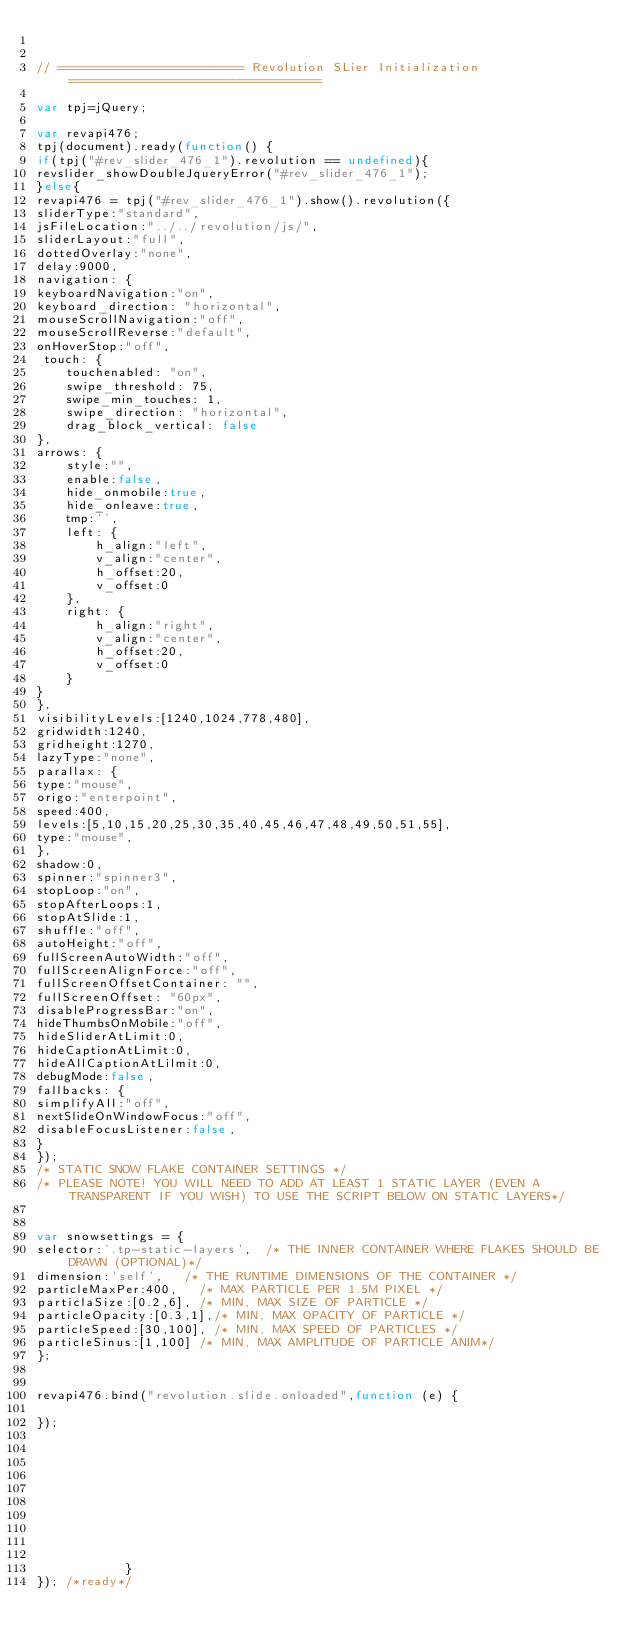<code> <loc_0><loc_0><loc_500><loc_500><_JavaScript_>

// ========================= Revolution SLier Initialization ==================================

var tpj=jQuery;

var revapi476;
tpj(document).ready(function() {
if(tpj("#rev_slider_476_1").revolution == undefined){
revslider_showDoubleJqueryError("#rev_slider_476_1");
}else{
revapi476 = tpj("#rev_slider_476_1").show().revolution({
sliderType:"standard",
jsFileLocation:"../../revolution/js/",
sliderLayout:"full",
dottedOverlay:"none",
delay:9000,
navigation: {
keyboardNavigation:"on",
keyboard_direction: "horizontal",
mouseScrollNavigation:"off",
mouseScrollReverse:"default",
onHoverStop:"off",
 touch: {
    touchenabled: "on",
    swipe_threshold: 75,
    swipe_min_touches: 1,
    swipe_direction: "horizontal",
    drag_block_vertical: false
},
arrows: {
    style:"",
    enable:false,
    hide_onmobile:true,
    hide_onleave:true,
    tmp:'',
    left: {
        h_align:"left",
        v_align:"center",
        h_offset:20,
        v_offset:0
    },
    right: {
        h_align:"right",
        v_align:"center",
        h_offset:20,
        v_offset:0
    }
}
},
visibilityLevels:[1240,1024,778,480],
gridwidth:1240,
gridheight:1270,
lazyType:"none",
parallax: {
type:"mouse",
origo:"enterpoint",
speed:400,
levels:[5,10,15,20,25,30,35,40,45,46,47,48,49,50,51,55],
type:"mouse",
},
shadow:0,
spinner:"spinner3",
stopLoop:"on",
stopAfterLoops:1,
stopAtSlide:1,
shuffle:"off",
autoHeight:"off",
fullScreenAutoWidth:"off",
fullScreenAlignForce:"off",
fullScreenOffsetContainer: "",
fullScreenOffset: "60px",
disableProgressBar:"on",
hideThumbsOnMobile:"off",
hideSliderAtLimit:0,
hideCaptionAtLimit:0,
hideAllCaptionAtLilmit:0,
debugMode:false,
fallbacks: {
simplifyAll:"off",
nextSlideOnWindowFocus:"off",
disableFocusListener:false,
}
});
/* STATIC SNOW FLAKE CONTAINER SETTINGS */
/* PLEASE NOTE! YOU WILL NEED TO ADD AT LEAST 1 STATIC LAYER (EVEN A TRANSPARENT IF YOU WISH) TO USE THE SCRIPT BELOW ON STATIC LAYERS*/


var snowsettings = {   
selector:'.tp-static-layers',  /* THE INNER CONTAINER WHERE FLAKES SHOULD BE DRAWN (OPTIONAL)*/
dimension:'self',   /* THE RUNTIME DIMENSIONS OF THE CONTAINER */
particleMaxPer:400,   /* MAX PARTICLE PER 1.5M PIXEL */ 
particlaSize:[0.2,6], /* MIN, MAX SIZE OF PARTICLE */
particleOpacity:[0.3,1],/* MIN, MAX OPACITY OF PARTICLE */
particleSpeed:[30,100], /* MIN, MAX SPEED OF PARTICLES */
particleSinus:[1,100] /* MIN, MAX AMPLITUDE OF PARTICLE ANIM*/
};


revapi476.bind("revolution.slide.onloaded",function (e) {
 
});










            }
}); /*ready*/
</code> 